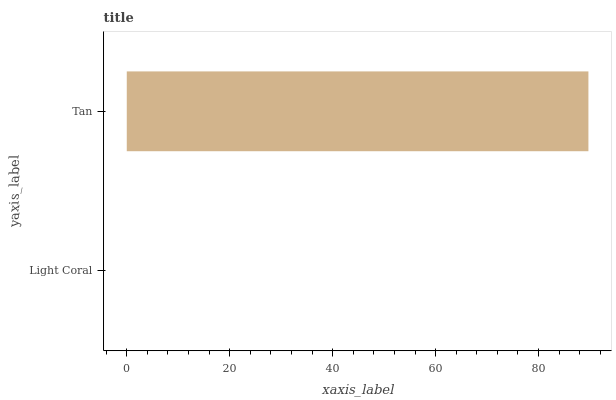Is Light Coral the minimum?
Answer yes or no. Yes. Is Tan the maximum?
Answer yes or no. Yes. Is Tan the minimum?
Answer yes or no. No. Is Tan greater than Light Coral?
Answer yes or no. Yes. Is Light Coral less than Tan?
Answer yes or no. Yes. Is Light Coral greater than Tan?
Answer yes or no. No. Is Tan less than Light Coral?
Answer yes or no. No. Is Tan the high median?
Answer yes or no. Yes. Is Light Coral the low median?
Answer yes or no. Yes. Is Light Coral the high median?
Answer yes or no. No. Is Tan the low median?
Answer yes or no. No. 